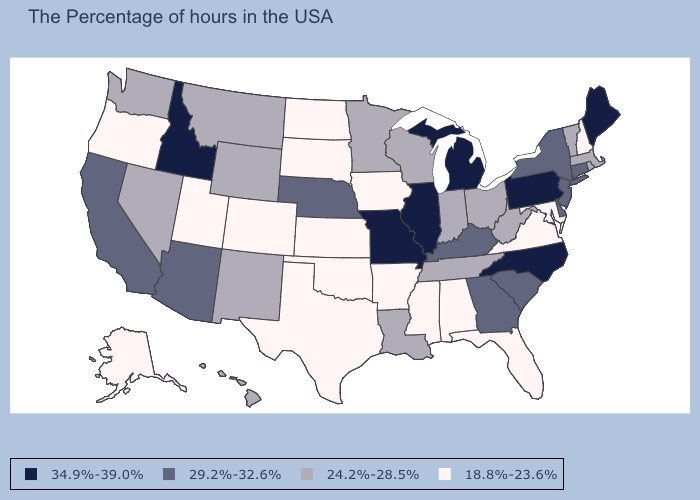Does the map have missing data?
Short answer required. No. Does Missouri have the highest value in the USA?
Keep it brief. Yes. What is the highest value in the USA?
Short answer required. 34.9%-39.0%. What is the value of Vermont?
Answer briefly. 24.2%-28.5%. What is the lowest value in the MidWest?
Be succinct. 18.8%-23.6%. What is the lowest value in the USA?
Answer briefly. 18.8%-23.6%. What is the highest value in the USA?
Keep it brief. 34.9%-39.0%. What is the lowest value in the USA?
Concise answer only. 18.8%-23.6%. What is the lowest value in states that border Washington?
Keep it brief. 18.8%-23.6%. Which states hav the highest value in the South?
Give a very brief answer. North Carolina. What is the value of Georgia?
Short answer required. 29.2%-32.6%. Name the states that have a value in the range 24.2%-28.5%?
Short answer required. Massachusetts, Rhode Island, Vermont, West Virginia, Ohio, Indiana, Tennessee, Wisconsin, Louisiana, Minnesota, Wyoming, New Mexico, Montana, Nevada, Washington, Hawaii. Does Arizona have a lower value than North Carolina?
Be succinct. Yes. Name the states that have a value in the range 34.9%-39.0%?
Short answer required. Maine, Pennsylvania, North Carolina, Michigan, Illinois, Missouri, Idaho. How many symbols are there in the legend?
Short answer required. 4. 